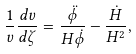Convert formula to latex. <formula><loc_0><loc_0><loc_500><loc_500>\frac { 1 } { v } \frac { d v } { d \zeta } = \frac { \ddot { \phi } } { H \dot { \phi } } - \frac { \dot { H } } { H ^ { 2 } } ,</formula> 